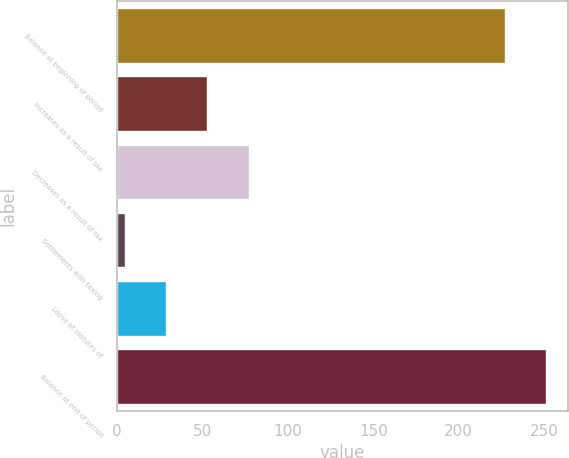Convert chart. <chart><loc_0><loc_0><loc_500><loc_500><bar_chart><fcel>Balance at beginning of period<fcel>Increases as a result of tax<fcel>Decreases as a result of tax<fcel>Settlements with taxing<fcel>Lapse of statutes of<fcel>Balance at end of period<nl><fcel>226.9<fcel>53.02<fcel>77.23<fcel>4.6<fcel>28.81<fcel>251.11<nl></chart> 